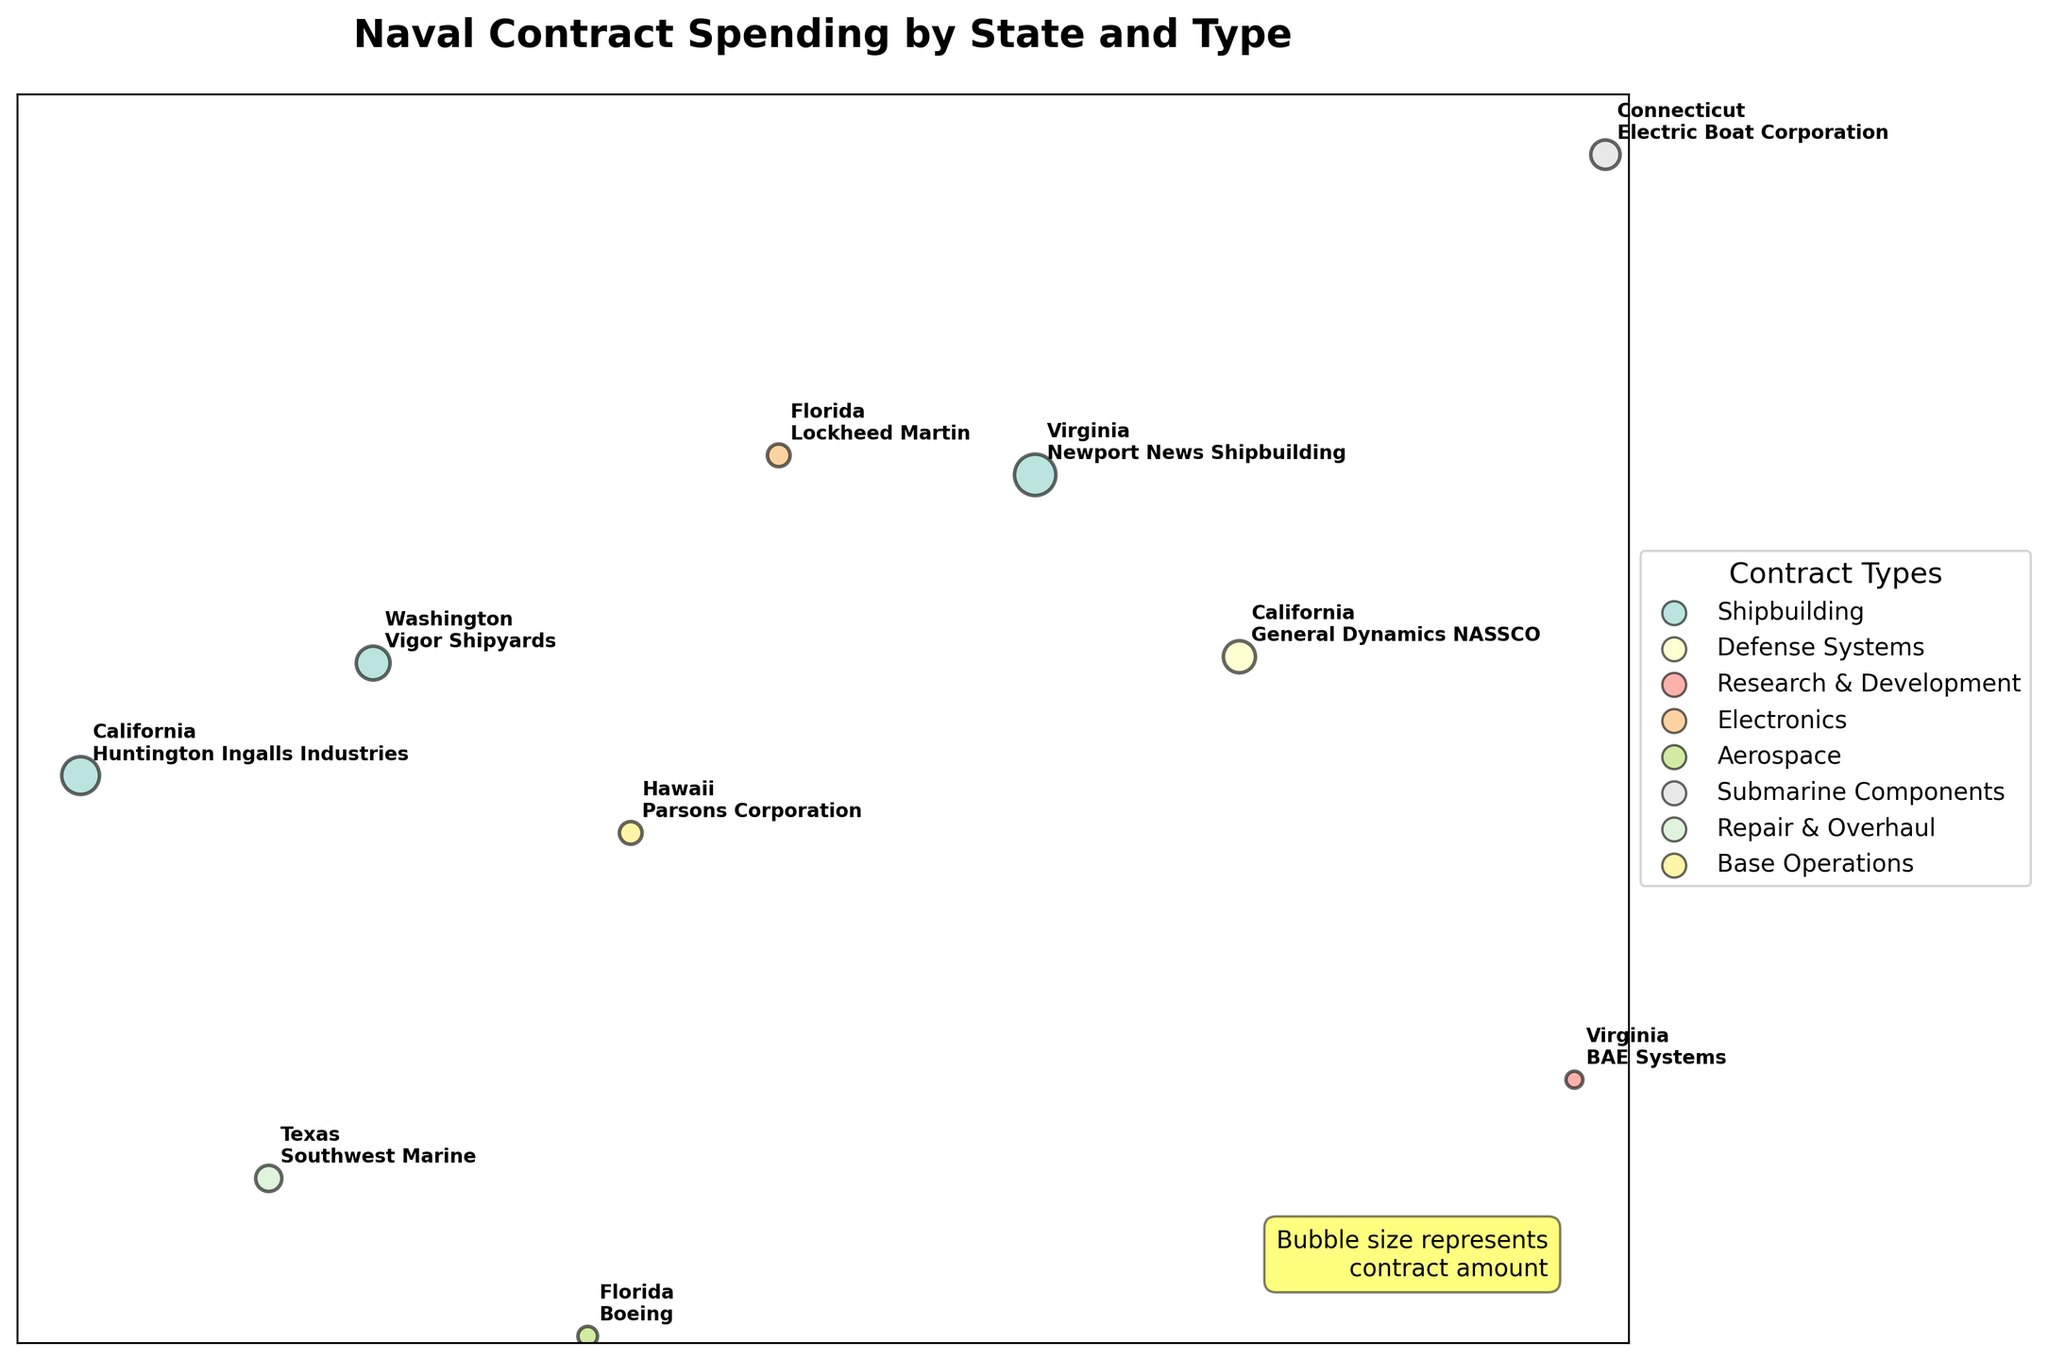What is the title of the plot? The title is usually placed at the top of the plot and provides a brief description of what the plot is about. By looking at the top, you will see "Naval Contract Spending by State and Type".
Answer: Naval Contract Spending by State and Type How many different contract types are shown in the plot? The different contract types can be identified by the colors in the legend on the right side of the plot. Each type will have a unique color label. There are 8 different contract types in the legend.
Answer: 8 Which state has the highest spending in the Shipbuilding contract type? The size of the bubbles represents the contract amount. By looking at the Shipbuilding contract type color and comparing the sizes of the bubbles, it's clear that Virginia has the largest bubble for Shipbuilding.
Answer: Virginia What is the total contract amount for California? Identify the bubbles representing California and sum their sizes. California has bubbles for Shipbuilding ($250,000,000) and Defense Systems ($180,000,000).
Answer: $430,000,000 Which contract type has the smallest bubble? Look at the legend to identify the colors for each contract type. Then, compare the sizes of the bubbles, the smallest bubble is for Research & Development in Virginia.
Answer: Research & Development Compare the contract amounts between Florida and Texas. Which state has a higher total amount? Locate the bubbles for Florida and Texas. Sum the contract amounts: Florida has Electronics ($90,000,000) and Aerospace ($67,000,000). Texas has one bubble for Repair & Overhaul ($120,000,000). Total amounts are $157,000,000 for Florida and $120,000,000 for Texas.
Answer: Florida Which state's contract recipient is Huntington Ingalls Industries? Look for the annotations on the bubbles. The state and recipient are written next to each bubble. Huntington Ingalls Industries is mentioned alongside a bubble in California.
Answer: California What is the average spending in each contract type? Sum up the spending for each contract type and divide by the number of contracts of that type. For example, Shipbuilding has two contracts ($250,000,000 + $300,000,000)/2. Repeat for all contract types. Shipbuilding: $275,000,000, Defense Systems: $180,000,000, Research & Development: $50,000,000, Electronics: $90,000,000, Aerospace: $67,000,000, Submarine Components: $150,000,000, Repair & Overhaul: $120,000,000, Base Operations: $90,000,000.
Answer: Varies by contract type What is the combined spending of Shipbuilding and Submarine Components contracts? Sum the amounts for these two contract types. Shipbuilding has $250,000,000 (California) + $300,000,000 (Virginia) and Submarine Components has $150,000,000 (Connecticut). Total = $250,000,000 + $300,000,000 + $150,000,000.
Answer: $700,000,000 Which states have only one contract type and what are they? Examine each state and see how many different colored bubbles (contract types) they have. States with only one type are Connecticut (Submarine Components), Texas (Repair & Overhaul), and Hawaii (Base Operations).
Answer: Connecticut, Texas, Hawaii 